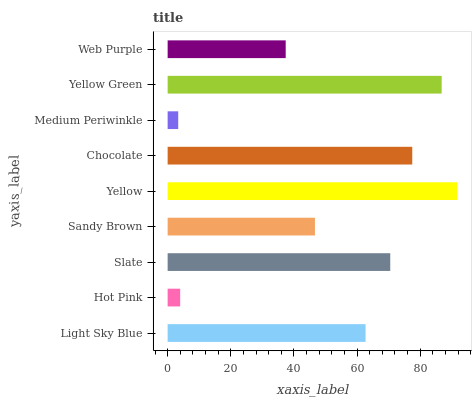Is Medium Periwinkle the minimum?
Answer yes or no. Yes. Is Yellow the maximum?
Answer yes or no. Yes. Is Hot Pink the minimum?
Answer yes or no. No. Is Hot Pink the maximum?
Answer yes or no. No. Is Light Sky Blue greater than Hot Pink?
Answer yes or no. Yes. Is Hot Pink less than Light Sky Blue?
Answer yes or no. Yes. Is Hot Pink greater than Light Sky Blue?
Answer yes or no. No. Is Light Sky Blue less than Hot Pink?
Answer yes or no. No. Is Light Sky Blue the high median?
Answer yes or no. Yes. Is Light Sky Blue the low median?
Answer yes or no. Yes. Is Yellow the high median?
Answer yes or no. No. Is Medium Periwinkle the low median?
Answer yes or no. No. 